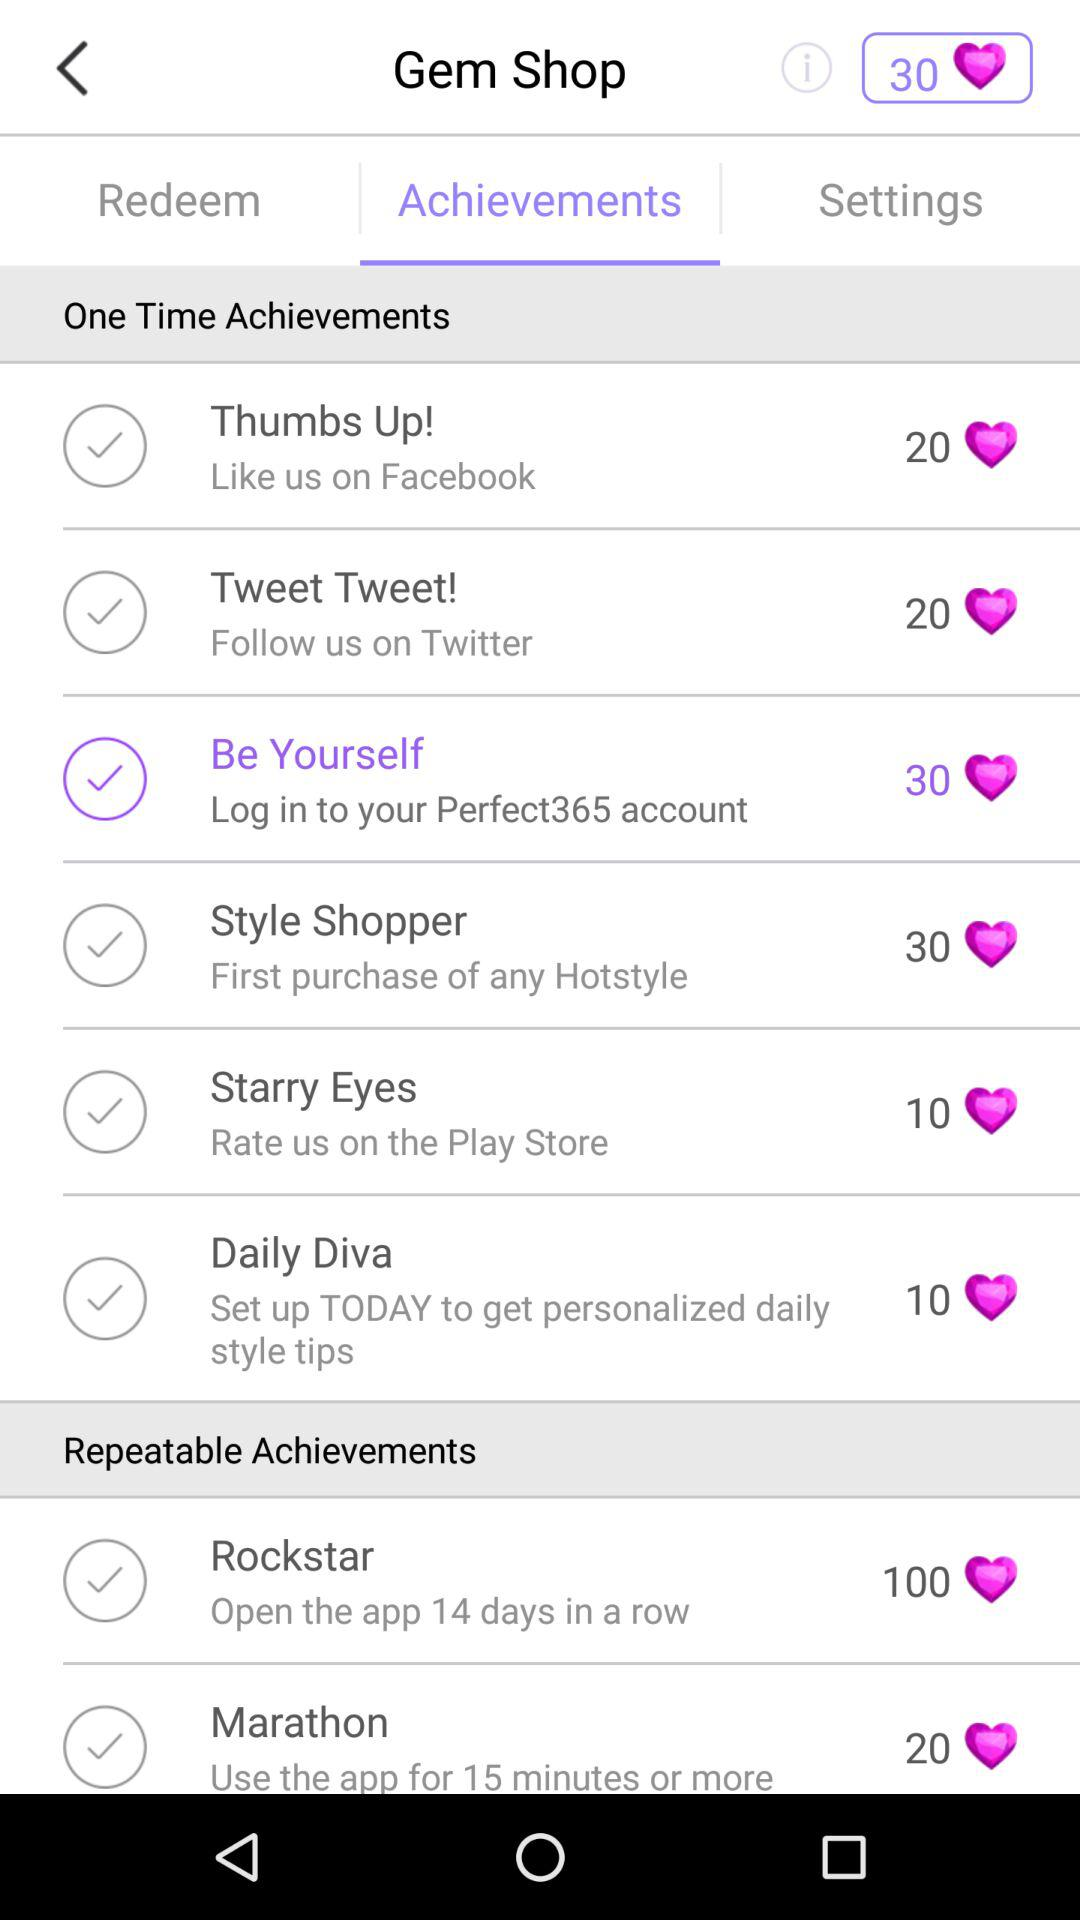How many hearts are there for "Style Shopper"? There are 30 hearts for "Style Shopper". 